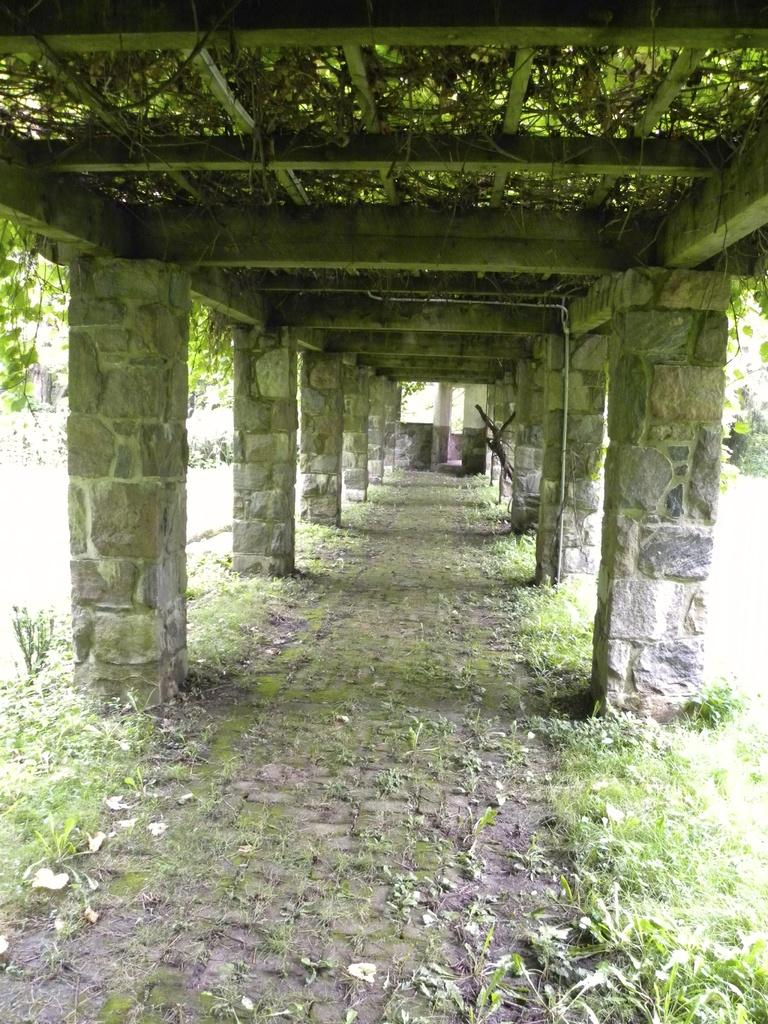What type of structure is present in the image? There is a pathway under a roof in the image. What supports the roof in the image? Pillars are present in the image to support the roof. What type of vegetation is visible in the image? Creepers and plants are visible in the image. What is on the ground in the image? Grass is on the ground in the image. What type of competition is taking place in the image? There is no competition present in the image; it features a pathway, pillars, creepers, plants, and grass. How does the zebra transport itself through the image? There is no zebra present in the image, so it cannot be transporting itself through it. 